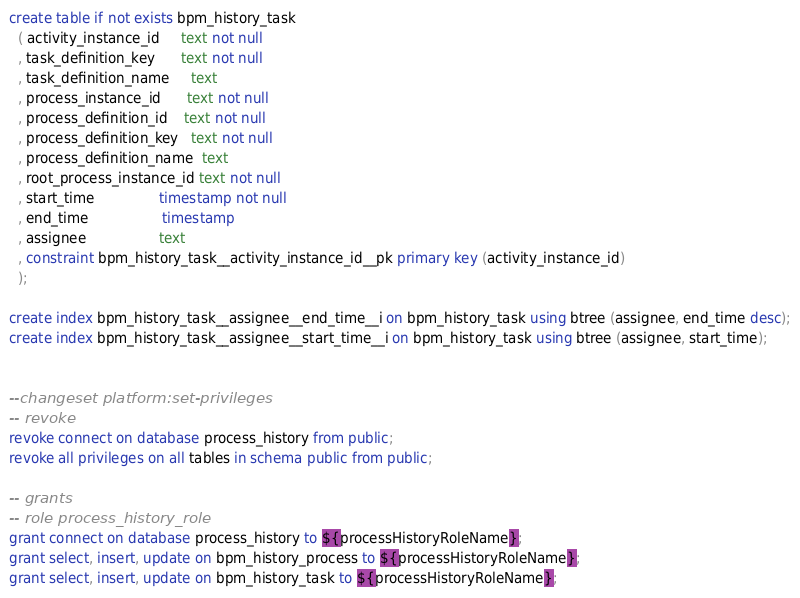Convert code to text. <code><loc_0><loc_0><loc_500><loc_500><_SQL_>create table if not exists bpm_history_task
  ( activity_instance_id     text not null
  , task_definition_key      text not null
  , task_definition_name     text
  , process_instance_id      text not null
  , process_definition_id    text not null
  , process_definition_key   text not null
  , process_definition_name  text
  , root_process_instance_id text not null
  , start_time               timestamp not null
  , end_time                 timestamp
  , assignee                 text
  , constraint bpm_history_task__activity_instance_id__pk primary key (activity_instance_id)
  );

create index bpm_history_task__assignee__end_time__i on bpm_history_task using btree (assignee, end_time desc);
create index bpm_history_task__assignee__start_time__i on bpm_history_task using btree (assignee, start_time);


--changeset platform:set-privileges
-- revoke
revoke connect on database process_history from public;
revoke all privileges on all tables in schema public from public;

-- grants
-- role process_history_role
grant connect on database process_history to ${processHistoryRoleName};
grant select, insert, update on bpm_history_process to ${processHistoryRoleName};
grant select, insert, update on bpm_history_task to ${processHistoryRoleName};
</code> 